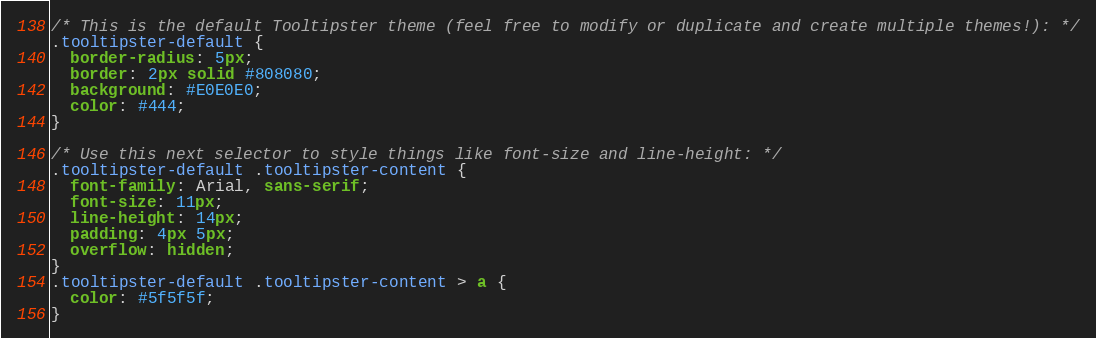Convert code to text. <code><loc_0><loc_0><loc_500><loc_500><_CSS_>/* This is the default Tooltipster theme (feel free to modify or duplicate and create multiple themes!): */
.tooltipster-default {
  border-radius: 5px;
  border: 2px solid #808080;
  background: #E0E0E0;
  color: #444;
}

/* Use this next selector to style things like font-size and line-height: */
.tooltipster-default .tooltipster-content {
  font-family: Arial, sans-serif;
  font-size: 11px;
  line-height: 14px;
  padding: 4px 5px;
  overflow: hidden;
}
.tooltipster-default .tooltipster-content > a {
  color: #5f5f5f;
}
</code> 